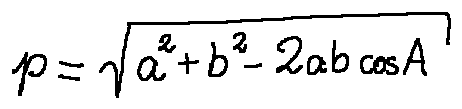Convert formula to latex. <formula><loc_0><loc_0><loc_500><loc_500>p = \sqrt { a ^ { 2 } + b ^ { 2 } - 2 a b \cos A }</formula> 